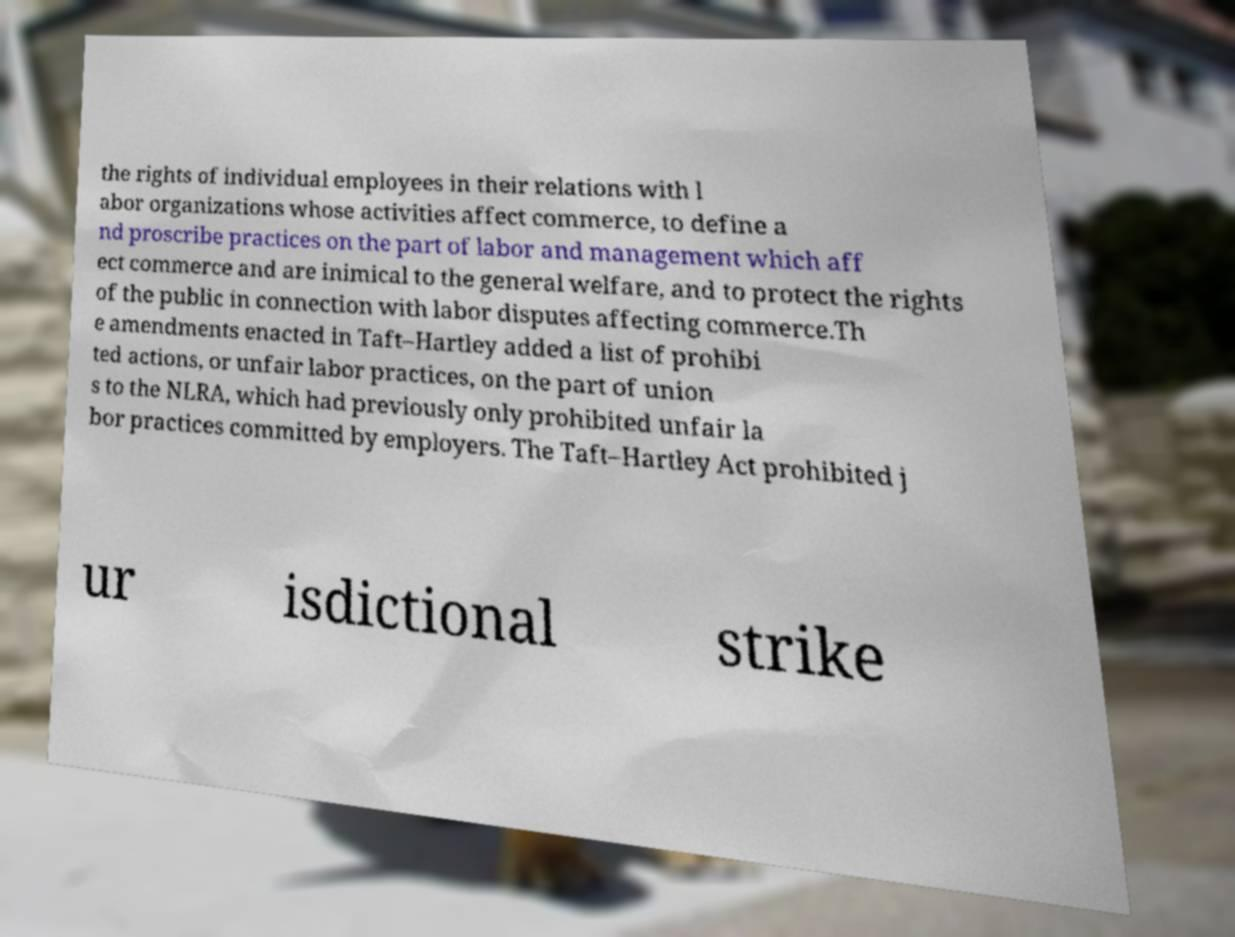I need the written content from this picture converted into text. Can you do that? the rights of individual employees in their relations with l abor organizations whose activities affect commerce, to define a nd proscribe practices on the part of labor and management which aff ect commerce and are inimical to the general welfare, and to protect the rights of the public in connection with labor disputes affecting commerce.Th e amendments enacted in Taft–Hartley added a list of prohibi ted actions, or unfair labor practices, on the part of union s to the NLRA, which had previously only prohibited unfair la bor practices committed by employers. The Taft–Hartley Act prohibited j ur isdictional strike 